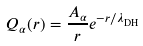Convert formula to latex. <formula><loc_0><loc_0><loc_500><loc_500>Q _ { \alpha } ( r ) = \frac { A _ { \alpha } } { r } e ^ { - r / \lambda _ { \text {DH} } }</formula> 